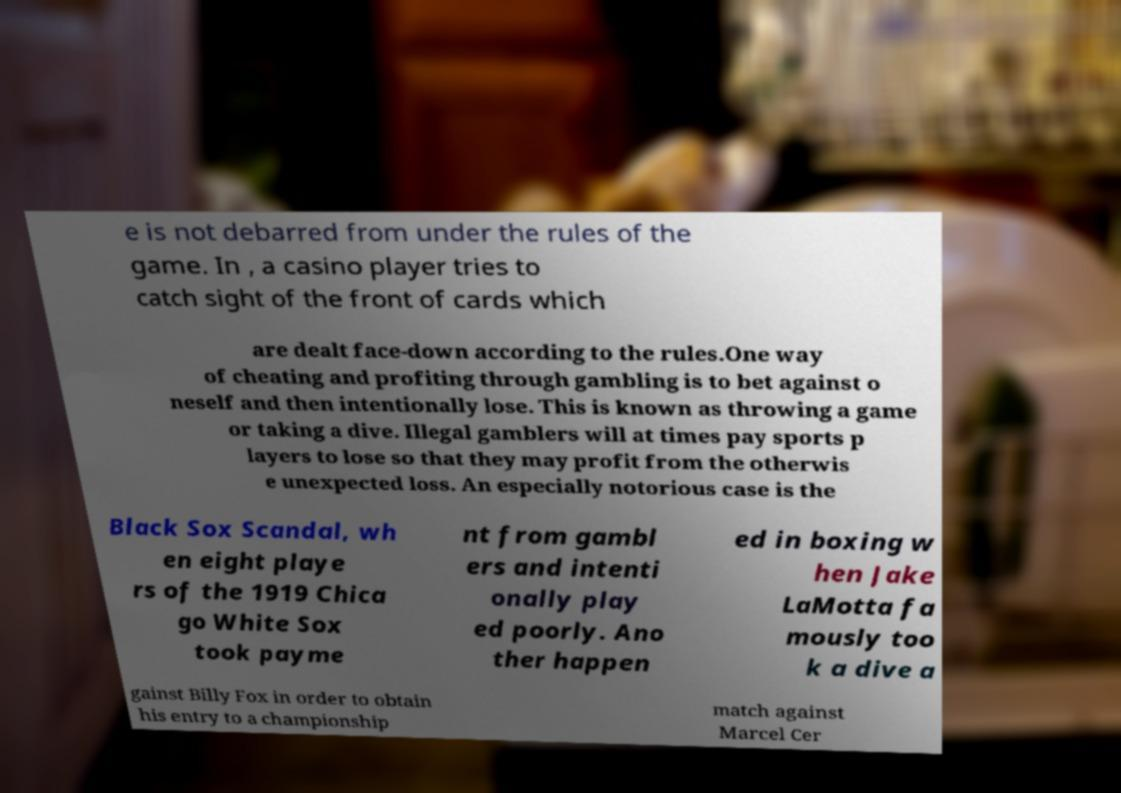Can you accurately transcribe the text from the provided image for me? e is not debarred from under the rules of the game. In , a casino player tries to catch sight of the front of cards which are dealt face-down according to the rules.One way of cheating and profiting through gambling is to bet against o neself and then intentionally lose. This is known as throwing a game or taking a dive. Illegal gamblers will at times pay sports p layers to lose so that they may profit from the otherwis e unexpected loss. An especially notorious case is the Black Sox Scandal, wh en eight playe rs of the 1919 Chica go White Sox took payme nt from gambl ers and intenti onally play ed poorly. Ano ther happen ed in boxing w hen Jake LaMotta fa mously too k a dive a gainst Billy Fox in order to obtain his entry to a championship match against Marcel Cer 